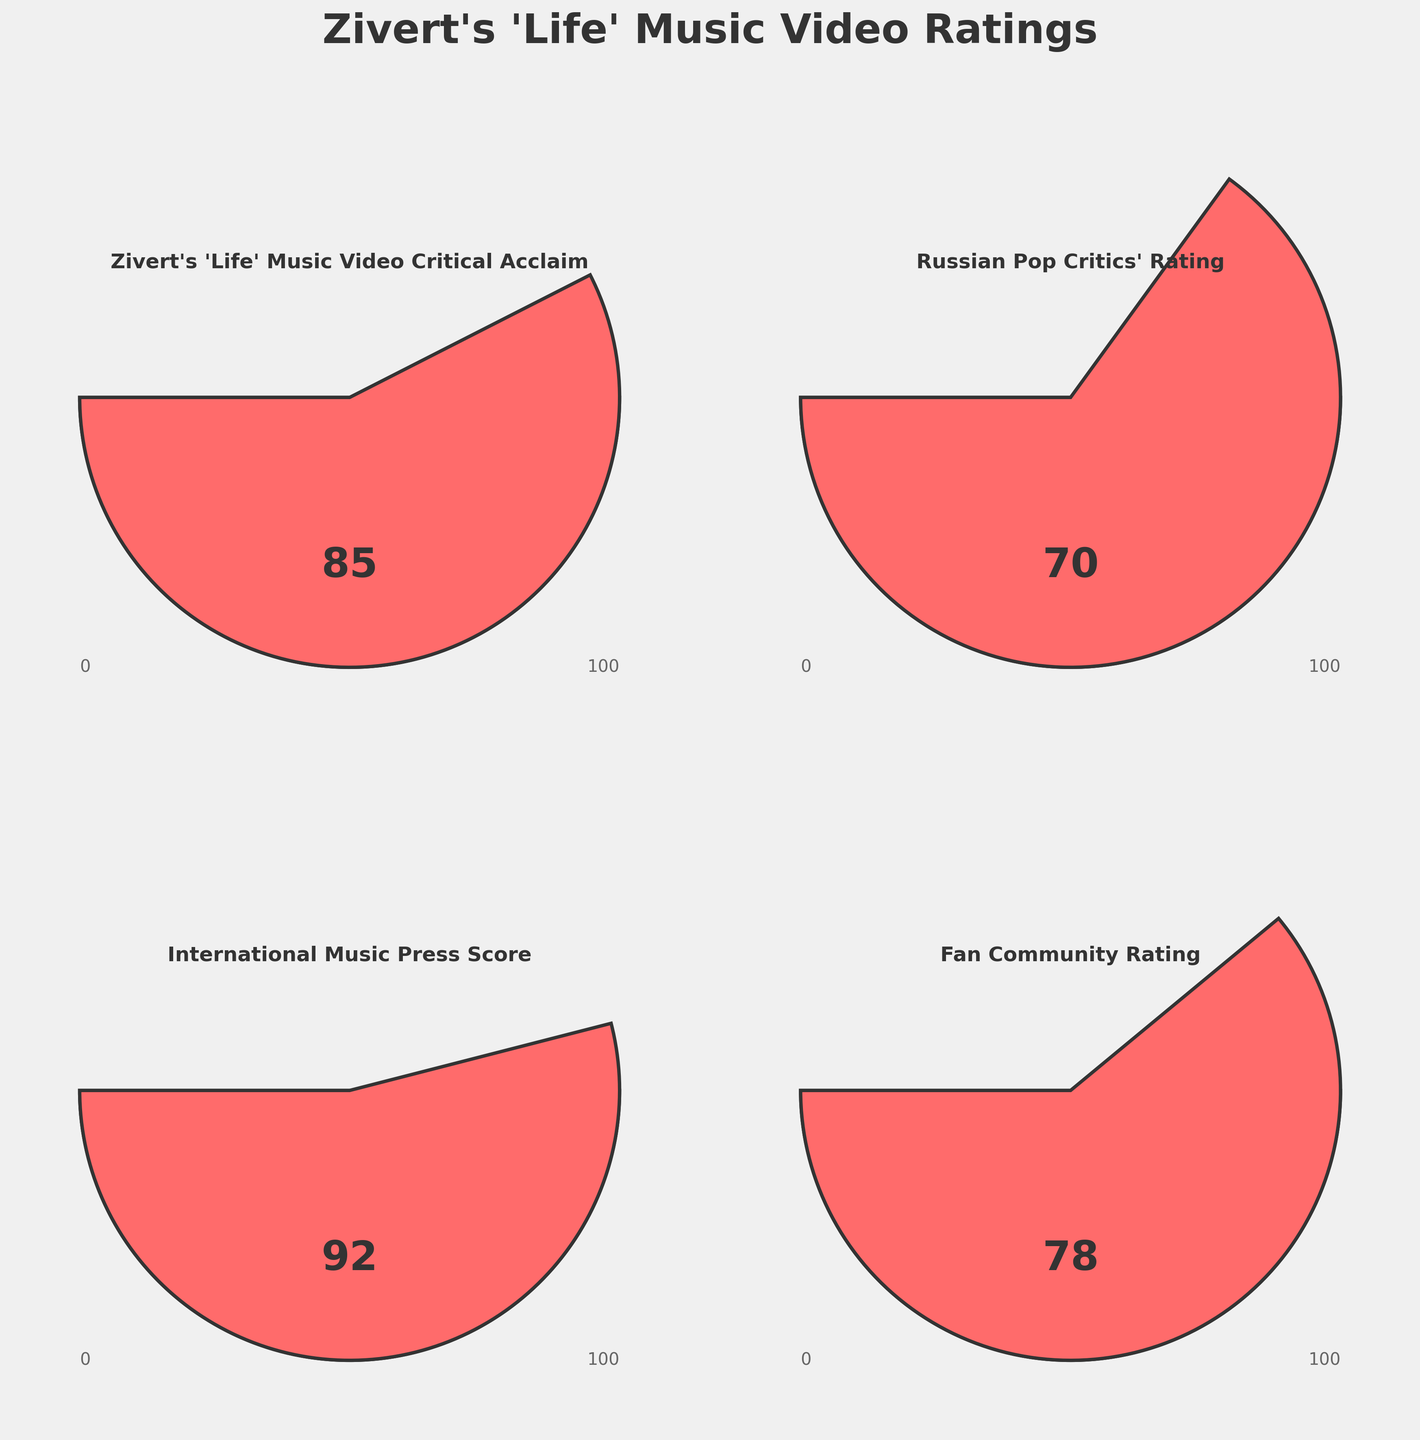What's the critical acclaim score for Zivert's 'Life' music video? The title under the first gauge label indicates "Zivert's 'Life' Music Video Critical Acclaim" with a score of 85.
Answer: 85 What's the score given by Russian Pop Critics? The title under the second gauge label indicates "Russian Pop Critics' Rating" with a score of 70.
Answer: 70 Which group gave the highest score to Zivert's 'Life' music video? By comparing the scores in all four gauges, the "International Music Press Score" is the highest at 92.
Answer: International Music Press What is the difference between the Fan Community Rating and the Russian Pop Critics' Rating? The Fan Community Rating is 78, and the Russian Pop Critics' Rating is 70. The difference is 78 - 70 = 8.
Answer: 8 What is the average score given by the Fan Community and Russian Pop Critics? The Fan Community Rating is 78 and the Russian Pop Critics' Rating is 70. The average is (78 + 70) / 2 = 74.
Answer: 74 How does the critical acclaim score compare to the average of all other groups' ratings? The other groups' ratings are 70, 92, and 78. Their average is (70 + 92 + 78) / 3 = 80. The critical acclaim score is 85, which is higher than the average of 80.
Answer: Higher What is the range of scores shown in the figure? The minimum value is 0, and the maximum value is 100, as shown at the bottom of each gauge. The range is 100 - 0 = 100.
Answer: 100 How does the International Music Press Score compare to the Critical Acclaim Score for Zivert's 'Life' music video? The International Music Press Score is 92, and the critical acclaim score for Zivert's 'Life' music video is 85. The International Music Press Score is higher.
Answer: Higher Among the ratings given, which one is closest to 75? The available scores are 85, 70, 92, and 78. The score 78 is the closest to 75.
Answer: 78 